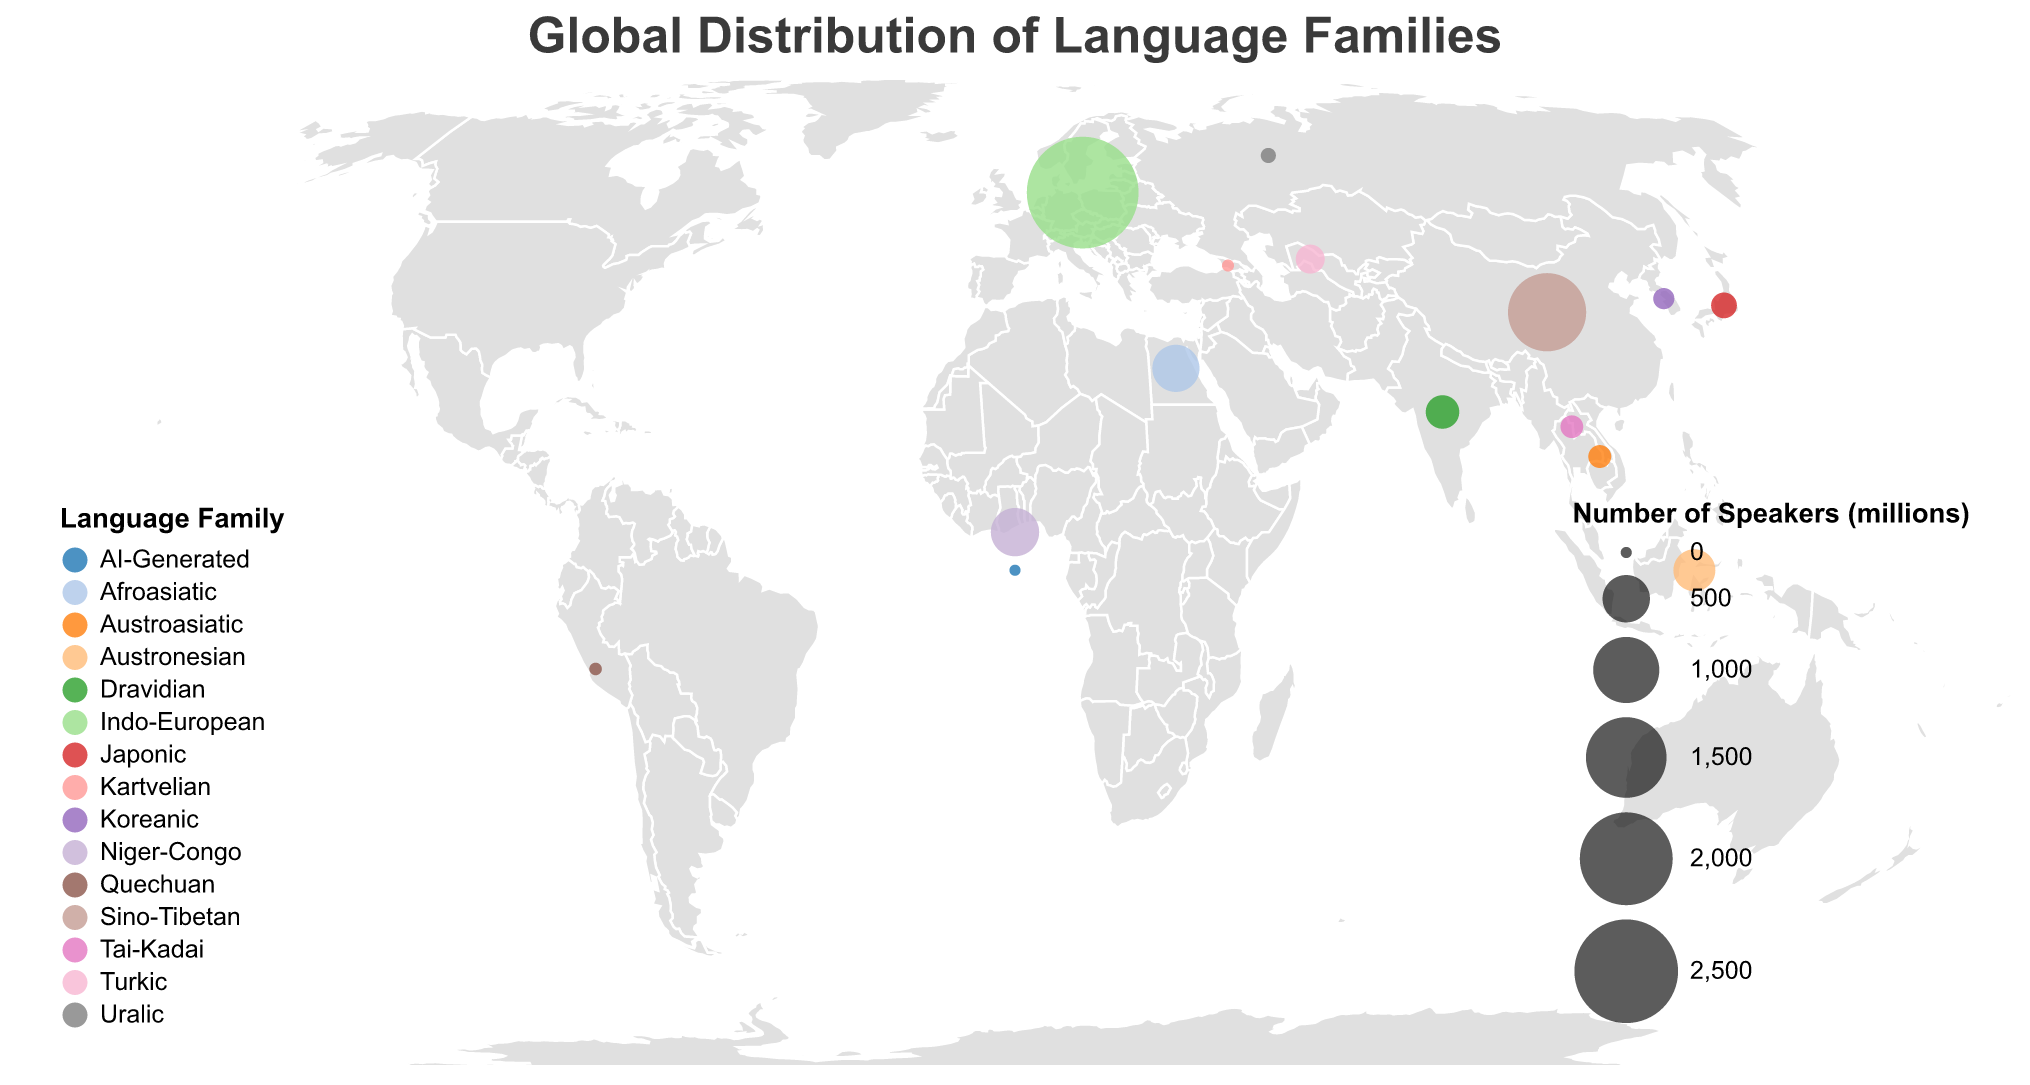What is the title of the figure? The title of the figure is displayed at the top in the largest font size. It reads "Global Distribution of Language Families".
Answer: Global Distribution of Language Families Which language family has the largest number of speakers? By looking at the size of the circles in the figure, the largest circle corresponds to the Indo-European language family. The tooltip also confirms this with 2910 million speakers.
Answer: Indo-European What is the number of speakers for the Niger-Congo language family? The size of the circle for the Niger-Congo family is checked and the tooltip indicates the number of speakers, which is 520 million.
Answer: 520 million How many regions have more than one language family represented in the figure? By examining the figure and noting the locations of various circles, it is evident that East Asia has three language families (Sino-Tibetan, Japonic, Koreanic), and Southeast Asia has three language families (Austronesian, Austroasiatic, Tai-Kadai).
Answer: 2 regions Which language families are found in Southeast Asia and what are their speaker numbers respectively? By inspecting the figure, locating Southeast Asia, and examining the tooltips for circles present there, we find Austronesian with 386 million speakers, Austroasiatic with 95 million speakers, and Tai-Kadai with 93 million speakers.
Answer: Austronesian: 386 million, Austroasiatic: 95 million, Tai-Kadai: 93 million Compare the number of speakers between the Turkic and the Dravidian language families. Which has more speakers and by how much? Checking the circles for the Turkic and Dravidian families and inspecting the tooltips shows Turkic with 170 million speakers and Dravidian with 237 million speakers. The difference is 237 - 170 = 67 million.
Answer: Dravidian has 67 million more speakers How does the number of speakers of the Austroasiatic family compare to that of the Tai-Kadai family? Inspecting the Southeast Asia region and corresponding tooltips shows Austroasiatic with 95 million speakers and Tai-Kadai with 93 million speakers.
Answer: Austroasiatic has 2 million more speakers Which language family has the least number of speakers and what is the exact number? Checking the smallest circle on the plot, the tooltip reveals AI-Generated language family with 0.1 million (100,000) speakers.
Answer: AI-Generated with 0.1 million speakers In which regions is the Afroasiatic language family primarily distributed? By finding the circle labeled Afroasiatic on the map and checking the tooltip, it is indicated the region as North Africa/Middle East.
Answer: North Africa/Middle East 